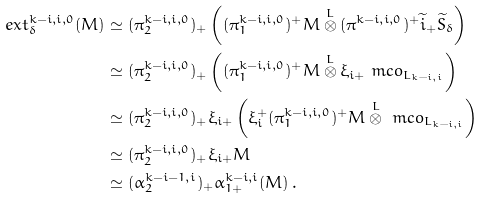Convert formula to latex. <formula><loc_0><loc_0><loc_500><loc_500>e x t ^ { k - i , i , 0 } _ { \delta } ( M ) & \simeq ( \pi _ { 2 } ^ { k - i , i , 0 } ) _ { + } \left ( ( \pi _ { 1 } ^ { k - i , i , 0 } ) ^ { + } M \overset { L } { \otimes } ( \pi ^ { k - i , i , 0 } ) ^ { + } \widetilde { i } _ { + } \widetilde { S } _ { \delta } \right ) \\ & \simeq ( \pi _ { 2 } ^ { k - i , i , 0 } ) _ { + } \left ( ( \pi _ { 1 } ^ { k - i , i , 0 } ) ^ { + } M \overset { L } { \otimes } \xi _ { i + } \ m c o _ { L _ { k - i , i } } \right ) \\ & \simeq ( \pi _ { 2 } ^ { k - i , i , 0 } ) _ { + } \xi _ { i + } \left ( \xi _ { i } ^ { + } ( \pi _ { 1 } ^ { k - i , i , 0 } ) ^ { + } M \overset { L } { \otimes } \ m c o _ { L _ { k - i , i } } \right ) \\ & \simeq ( \pi _ { 2 } ^ { k - i , i , 0 } ) _ { + } \xi _ { i + } M \\ & \simeq ( \alpha _ { 2 } ^ { k - i - 1 , i } ) _ { + } \alpha _ { 1 + } ^ { k - i , i } ( M ) \, .</formula> 